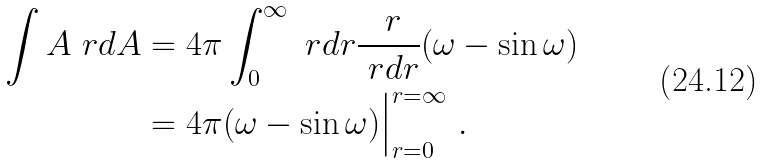Convert formula to latex. <formula><loc_0><loc_0><loc_500><loc_500>\int A \ r d A & = 4 \pi \int _ { 0 } ^ { \infty } \ r d r \frac { \ r } { \ r d r } ( \omega - \sin \omega ) \\ & = 4 \pi ( \omega - \sin \omega ) \Big | _ { r = 0 } ^ { r = \infty } \ .</formula> 